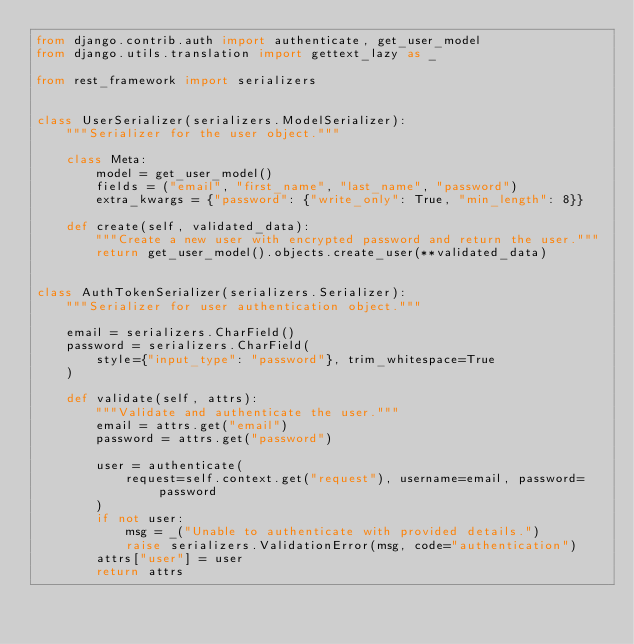Convert code to text. <code><loc_0><loc_0><loc_500><loc_500><_Python_>from django.contrib.auth import authenticate, get_user_model
from django.utils.translation import gettext_lazy as _

from rest_framework import serializers


class UserSerializer(serializers.ModelSerializer):
    """Serializer for the user object."""

    class Meta:
        model = get_user_model()
        fields = ("email", "first_name", "last_name", "password")
        extra_kwargs = {"password": {"write_only": True, "min_length": 8}}

    def create(self, validated_data):
        """Create a new user with encrypted password and return the user."""
        return get_user_model().objects.create_user(**validated_data)


class AuthTokenSerializer(serializers.Serializer):
    """Serializer for user authentication object."""

    email = serializers.CharField()
    password = serializers.CharField(
        style={"input_type": "password"}, trim_whitespace=True
    )

    def validate(self, attrs):
        """Validate and authenticate the user."""
        email = attrs.get("email")
        password = attrs.get("password")

        user = authenticate(
            request=self.context.get("request"), username=email, password=password
        )
        if not user:
            msg = _("Unable to authenticate with provided details.")
            raise serializers.ValidationError(msg, code="authentication")
        attrs["user"] = user
        return attrs
</code> 